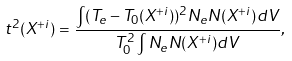Convert formula to latex. <formula><loc_0><loc_0><loc_500><loc_500>t ^ { 2 } ( X ^ { + i } ) = \frac { \int ( T _ { e } - T _ { 0 } ( X ^ { + i } ) ) ^ { 2 } N _ { e } N ( X ^ { + i } ) d V } { T _ { 0 } ^ { 2 } \int N _ { e } N ( X ^ { + i } ) d V } ,</formula> 